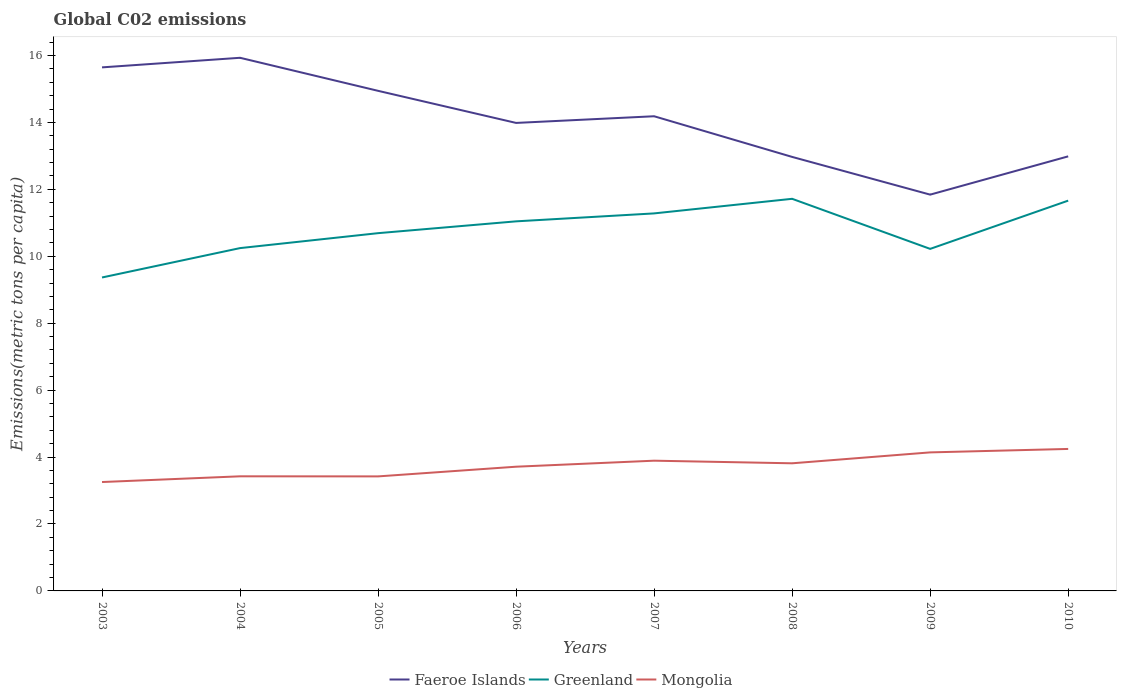Is the number of lines equal to the number of legend labels?
Keep it short and to the point. Yes. Across all years, what is the maximum amount of CO2 emitted in in Mongolia?
Provide a short and direct response. 3.25. What is the total amount of CO2 emitted in in Faeroe Islands in the graph?
Offer a terse response. 1.2. What is the difference between the highest and the second highest amount of CO2 emitted in in Faeroe Islands?
Provide a short and direct response. 4.09. What is the difference between the highest and the lowest amount of CO2 emitted in in Greenland?
Your answer should be compact. 4. How many lines are there?
Give a very brief answer. 3. Does the graph contain any zero values?
Keep it short and to the point. No. Does the graph contain grids?
Ensure brevity in your answer.  No. How are the legend labels stacked?
Offer a terse response. Horizontal. What is the title of the graph?
Your response must be concise. Global C02 emissions. What is the label or title of the Y-axis?
Provide a short and direct response. Emissions(metric tons per capita). What is the Emissions(metric tons per capita) in Faeroe Islands in 2003?
Offer a very short reply. 15.65. What is the Emissions(metric tons per capita) of Greenland in 2003?
Offer a very short reply. 9.37. What is the Emissions(metric tons per capita) in Mongolia in 2003?
Provide a short and direct response. 3.25. What is the Emissions(metric tons per capita) of Faeroe Islands in 2004?
Give a very brief answer. 15.93. What is the Emissions(metric tons per capita) of Greenland in 2004?
Give a very brief answer. 10.24. What is the Emissions(metric tons per capita) in Mongolia in 2004?
Ensure brevity in your answer.  3.43. What is the Emissions(metric tons per capita) in Faeroe Islands in 2005?
Your answer should be very brief. 14.95. What is the Emissions(metric tons per capita) of Greenland in 2005?
Make the answer very short. 10.69. What is the Emissions(metric tons per capita) in Mongolia in 2005?
Offer a very short reply. 3.42. What is the Emissions(metric tons per capita) in Faeroe Islands in 2006?
Keep it short and to the point. 13.99. What is the Emissions(metric tons per capita) in Greenland in 2006?
Offer a terse response. 11.04. What is the Emissions(metric tons per capita) of Mongolia in 2006?
Give a very brief answer. 3.71. What is the Emissions(metric tons per capita) in Faeroe Islands in 2007?
Ensure brevity in your answer.  14.19. What is the Emissions(metric tons per capita) in Greenland in 2007?
Provide a short and direct response. 11.28. What is the Emissions(metric tons per capita) in Mongolia in 2007?
Provide a short and direct response. 3.89. What is the Emissions(metric tons per capita) in Faeroe Islands in 2008?
Ensure brevity in your answer.  12.97. What is the Emissions(metric tons per capita) in Greenland in 2008?
Your answer should be very brief. 11.72. What is the Emissions(metric tons per capita) in Mongolia in 2008?
Provide a succinct answer. 3.81. What is the Emissions(metric tons per capita) in Faeroe Islands in 2009?
Ensure brevity in your answer.  11.84. What is the Emissions(metric tons per capita) of Greenland in 2009?
Provide a short and direct response. 10.22. What is the Emissions(metric tons per capita) of Mongolia in 2009?
Make the answer very short. 4.14. What is the Emissions(metric tons per capita) in Faeroe Islands in 2010?
Your answer should be compact. 12.99. What is the Emissions(metric tons per capita) of Greenland in 2010?
Your answer should be very brief. 11.66. What is the Emissions(metric tons per capita) in Mongolia in 2010?
Offer a terse response. 4.24. Across all years, what is the maximum Emissions(metric tons per capita) of Faeroe Islands?
Offer a very short reply. 15.93. Across all years, what is the maximum Emissions(metric tons per capita) in Greenland?
Ensure brevity in your answer.  11.72. Across all years, what is the maximum Emissions(metric tons per capita) in Mongolia?
Provide a short and direct response. 4.24. Across all years, what is the minimum Emissions(metric tons per capita) in Faeroe Islands?
Your answer should be very brief. 11.84. Across all years, what is the minimum Emissions(metric tons per capita) in Greenland?
Offer a very short reply. 9.37. Across all years, what is the minimum Emissions(metric tons per capita) in Mongolia?
Your answer should be compact. 3.25. What is the total Emissions(metric tons per capita) of Faeroe Islands in the graph?
Provide a succinct answer. 112.49. What is the total Emissions(metric tons per capita) of Greenland in the graph?
Offer a very short reply. 86.23. What is the total Emissions(metric tons per capita) of Mongolia in the graph?
Provide a succinct answer. 29.9. What is the difference between the Emissions(metric tons per capita) of Faeroe Islands in 2003 and that in 2004?
Offer a very short reply. -0.29. What is the difference between the Emissions(metric tons per capita) in Greenland in 2003 and that in 2004?
Provide a short and direct response. -0.88. What is the difference between the Emissions(metric tons per capita) of Mongolia in 2003 and that in 2004?
Your answer should be compact. -0.17. What is the difference between the Emissions(metric tons per capita) in Faeroe Islands in 2003 and that in 2005?
Offer a very short reply. 0.7. What is the difference between the Emissions(metric tons per capita) of Greenland in 2003 and that in 2005?
Make the answer very short. -1.32. What is the difference between the Emissions(metric tons per capita) in Mongolia in 2003 and that in 2005?
Your response must be concise. -0.17. What is the difference between the Emissions(metric tons per capita) in Faeroe Islands in 2003 and that in 2006?
Keep it short and to the point. 1.66. What is the difference between the Emissions(metric tons per capita) in Greenland in 2003 and that in 2006?
Your answer should be very brief. -1.68. What is the difference between the Emissions(metric tons per capita) of Mongolia in 2003 and that in 2006?
Your response must be concise. -0.46. What is the difference between the Emissions(metric tons per capita) of Faeroe Islands in 2003 and that in 2007?
Your response must be concise. 1.46. What is the difference between the Emissions(metric tons per capita) of Greenland in 2003 and that in 2007?
Your answer should be compact. -1.92. What is the difference between the Emissions(metric tons per capita) in Mongolia in 2003 and that in 2007?
Your response must be concise. -0.64. What is the difference between the Emissions(metric tons per capita) in Faeroe Islands in 2003 and that in 2008?
Provide a succinct answer. 2.68. What is the difference between the Emissions(metric tons per capita) in Greenland in 2003 and that in 2008?
Offer a very short reply. -2.35. What is the difference between the Emissions(metric tons per capita) of Mongolia in 2003 and that in 2008?
Your answer should be compact. -0.56. What is the difference between the Emissions(metric tons per capita) of Faeroe Islands in 2003 and that in 2009?
Make the answer very short. 3.8. What is the difference between the Emissions(metric tons per capita) of Greenland in 2003 and that in 2009?
Give a very brief answer. -0.85. What is the difference between the Emissions(metric tons per capita) of Mongolia in 2003 and that in 2009?
Ensure brevity in your answer.  -0.89. What is the difference between the Emissions(metric tons per capita) of Faeroe Islands in 2003 and that in 2010?
Offer a terse response. 2.66. What is the difference between the Emissions(metric tons per capita) in Greenland in 2003 and that in 2010?
Your response must be concise. -2.3. What is the difference between the Emissions(metric tons per capita) in Mongolia in 2003 and that in 2010?
Keep it short and to the point. -0.99. What is the difference between the Emissions(metric tons per capita) in Faeroe Islands in 2004 and that in 2005?
Keep it short and to the point. 0.99. What is the difference between the Emissions(metric tons per capita) of Greenland in 2004 and that in 2005?
Offer a terse response. -0.45. What is the difference between the Emissions(metric tons per capita) of Mongolia in 2004 and that in 2005?
Offer a very short reply. 0. What is the difference between the Emissions(metric tons per capita) in Faeroe Islands in 2004 and that in 2006?
Provide a succinct answer. 1.95. What is the difference between the Emissions(metric tons per capita) in Greenland in 2004 and that in 2006?
Ensure brevity in your answer.  -0.8. What is the difference between the Emissions(metric tons per capita) of Mongolia in 2004 and that in 2006?
Your answer should be very brief. -0.29. What is the difference between the Emissions(metric tons per capita) of Faeroe Islands in 2004 and that in 2007?
Your answer should be very brief. 1.75. What is the difference between the Emissions(metric tons per capita) in Greenland in 2004 and that in 2007?
Offer a very short reply. -1.04. What is the difference between the Emissions(metric tons per capita) of Mongolia in 2004 and that in 2007?
Ensure brevity in your answer.  -0.47. What is the difference between the Emissions(metric tons per capita) of Faeroe Islands in 2004 and that in 2008?
Offer a terse response. 2.96. What is the difference between the Emissions(metric tons per capita) of Greenland in 2004 and that in 2008?
Offer a very short reply. -1.47. What is the difference between the Emissions(metric tons per capita) of Mongolia in 2004 and that in 2008?
Ensure brevity in your answer.  -0.39. What is the difference between the Emissions(metric tons per capita) of Faeroe Islands in 2004 and that in 2009?
Give a very brief answer. 4.09. What is the difference between the Emissions(metric tons per capita) of Greenland in 2004 and that in 2009?
Offer a terse response. 0.02. What is the difference between the Emissions(metric tons per capita) in Mongolia in 2004 and that in 2009?
Make the answer very short. -0.71. What is the difference between the Emissions(metric tons per capita) of Faeroe Islands in 2004 and that in 2010?
Make the answer very short. 2.95. What is the difference between the Emissions(metric tons per capita) in Greenland in 2004 and that in 2010?
Ensure brevity in your answer.  -1.42. What is the difference between the Emissions(metric tons per capita) of Mongolia in 2004 and that in 2010?
Provide a short and direct response. -0.82. What is the difference between the Emissions(metric tons per capita) in Greenland in 2005 and that in 2006?
Your answer should be compact. -0.35. What is the difference between the Emissions(metric tons per capita) in Mongolia in 2005 and that in 2006?
Provide a succinct answer. -0.29. What is the difference between the Emissions(metric tons per capita) of Faeroe Islands in 2005 and that in 2007?
Your answer should be compact. 0.76. What is the difference between the Emissions(metric tons per capita) in Greenland in 2005 and that in 2007?
Keep it short and to the point. -0.59. What is the difference between the Emissions(metric tons per capita) in Mongolia in 2005 and that in 2007?
Your answer should be compact. -0.47. What is the difference between the Emissions(metric tons per capita) in Faeroe Islands in 2005 and that in 2008?
Provide a succinct answer. 1.97. What is the difference between the Emissions(metric tons per capita) of Greenland in 2005 and that in 2008?
Make the answer very short. -1.03. What is the difference between the Emissions(metric tons per capita) of Mongolia in 2005 and that in 2008?
Your answer should be very brief. -0.39. What is the difference between the Emissions(metric tons per capita) in Faeroe Islands in 2005 and that in 2009?
Ensure brevity in your answer.  3.1. What is the difference between the Emissions(metric tons per capita) in Greenland in 2005 and that in 2009?
Provide a short and direct response. 0.47. What is the difference between the Emissions(metric tons per capita) in Mongolia in 2005 and that in 2009?
Ensure brevity in your answer.  -0.72. What is the difference between the Emissions(metric tons per capita) of Faeroe Islands in 2005 and that in 2010?
Make the answer very short. 1.96. What is the difference between the Emissions(metric tons per capita) in Greenland in 2005 and that in 2010?
Ensure brevity in your answer.  -0.97. What is the difference between the Emissions(metric tons per capita) of Mongolia in 2005 and that in 2010?
Your response must be concise. -0.82. What is the difference between the Emissions(metric tons per capita) in Faeroe Islands in 2006 and that in 2007?
Provide a succinct answer. -0.2. What is the difference between the Emissions(metric tons per capita) in Greenland in 2006 and that in 2007?
Offer a terse response. -0.24. What is the difference between the Emissions(metric tons per capita) in Mongolia in 2006 and that in 2007?
Give a very brief answer. -0.18. What is the difference between the Emissions(metric tons per capita) in Greenland in 2006 and that in 2008?
Your response must be concise. -0.67. What is the difference between the Emissions(metric tons per capita) in Mongolia in 2006 and that in 2008?
Make the answer very short. -0.1. What is the difference between the Emissions(metric tons per capita) in Faeroe Islands in 2006 and that in 2009?
Offer a terse response. 2.14. What is the difference between the Emissions(metric tons per capita) in Greenland in 2006 and that in 2009?
Ensure brevity in your answer.  0.82. What is the difference between the Emissions(metric tons per capita) of Mongolia in 2006 and that in 2009?
Your answer should be very brief. -0.43. What is the difference between the Emissions(metric tons per capita) in Greenland in 2006 and that in 2010?
Keep it short and to the point. -0.62. What is the difference between the Emissions(metric tons per capita) of Mongolia in 2006 and that in 2010?
Ensure brevity in your answer.  -0.53. What is the difference between the Emissions(metric tons per capita) of Faeroe Islands in 2007 and that in 2008?
Give a very brief answer. 1.22. What is the difference between the Emissions(metric tons per capita) of Greenland in 2007 and that in 2008?
Your response must be concise. -0.44. What is the difference between the Emissions(metric tons per capita) of Mongolia in 2007 and that in 2008?
Give a very brief answer. 0.08. What is the difference between the Emissions(metric tons per capita) of Faeroe Islands in 2007 and that in 2009?
Make the answer very short. 2.34. What is the difference between the Emissions(metric tons per capita) of Greenland in 2007 and that in 2009?
Your answer should be compact. 1.06. What is the difference between the Emissions(metric tons per capita) in Mongolia in 2007 and that in 2009?
Provide a succinct answer. -0.25. What is the difference between the Emissions(metric tons per capita) of Faeroe Islands in 2007 and that in 2010?
Your answer should be very brief. 1.2. What is the difference between the Emissions(metric tons per capita) of Greenland in 2007 and that in 2010?
Offer a terse response. -0.38. What is the difference between the Emissions(metric tons per capita) in Mongolia in 2007 and that in 2010?
Your answer should be very brief. -0.35. What is the difference between the Emissions(metric tons per capita) of Faeroe Islands in 2008 and that in 2009?
Make the answer very short. 1.13. What is the difference between the Emissions(metric tons per capita) of Greenland in 2008 and that in 2009?
Give a very brief answer. 1.5. What is the difference between the Emissions(metric tons per capita) of Mongolia in 2008 and that in 2009?
Give a very brief answer. -0.33. What is the difference between the Emissions(metric tons per capita) in Faeroe Islands in 2008 and that in 2010?
Give a very brief answer. -0.02. What is the difference between the Emissions(metric tons per capita) of Greenland in 2008 and that in 2010?
Provide a succinct answer. 0.05. What is the difference between the Emissions(metric tons per capita) of Mongolia in 2008 and that in 2010?
Your answer should be compact. -0.43. What is the difference between the Emissions(metric tons per capita) in Faeroe Islands in 2009 and that in 2010?
Your answer should be very brief. -1.14. What is the difference between the Emissions(metric tons per capita) of Greenland in 2009 and that in 2010?
Provide a succinct answer. -1.44. What is the difference between the Emissions(metric tons per capita) of Mongolia in 2009 and that in 2010?
Provide a succinct answer. -0.1. What is the difference between the Emissions(metric tons per capita) of Faeroe Islands in 2003 and the Emissions(metric tons per capita) of Greenland in 2004?
Provide a short and direct response. 5.4. What is the difference between the Emissions(metric tons per capita) in Faeroe Islands in 2003 and the Emissions(metric tons per capita) in Mongolia in 2004?
Your answer should be compact. 12.22. What is the difference between the Emissions(metric tons per capita) of Greenland in 2003 and the Emissions(metric tons per capita) of Mongolia in 2004?
Offer a terse response. 5.94. What is the difference between the Emissions(metric tons per capita) in Faeroe Islands in 2003 and the Emissions(metric tons per capita) in Greenland in 2005?
Your answer should be very brief. 4.95. What is the difference between the Emissions(metric tons per capita) in Faeroe Islands in 2003 and the Emissions(metric tons per capita) in Mongolia in 2005?
Your response must be concise. 12.22. What is the difference between the Emissions(metric tons per capita) of Greenland in 2003 and the Emissions(metric tons per capita) of Mongolia in 2005?
Offer a terse response. 5.94. What is the difference between the Emissions(metric tons per capita) in Faeroe Islands in 2003 and the Emissions(metric tons per capita) in Greenland in 2006?
Keep it short and to the point. 4.6. What is the difference between the Emissions(metric tons per capita) in Faeroe Islands in 2003 and the Emissions(metric tons per capita) in Mongolia in 2006?
Give a very brief answer. 11.93. What is the difference between the Emissions(metric tons per capita) of Greenland in 2003 and the Emissions(metric tons per capita) of Mongolia in 2006?
Give a very brief answer. 5.65. What is the difference between the Emissions(metric tons per capita) of Faeroe Islands in 2003 and the Emissions(metric tons per capita) of Greenland in 2007?
Provide a short and direct response. 4.36. What is the difference between the Emissions(metric tons per capita) in Faeroe Islands in 2003 and the Emissions(metric tons per capita) in Mongolia in 2007?
Provide a succinct answer. 11.75. What is the difference between the Emissions(metric tons per capita) in Greenland in 2003 and the Emissions(metric tons per capita) in Mongolia in 2007?
Offer a terse response. 5.47. What is the difference between the Emissions(metric tons per capita) in Faeroe Islands in 2003 and the Emissions(metric tons per capita) in Greenland in 2008?
Provide a succinct answer. 3.93. What is the difference between the Emissions(metric tons per capita) in Faeroe Islands in 2003 and the Emissions(metric tons per capita) in Mongolia in 2008?
Ensure brevity in your answer.  11.83. What is the difference between the Emissions(metric tons per capita) of Greenland in 2003 and the Emissions(metric tons per capita) of Mongolia in 2008?
Your response must be concise. 5.55. What is the difference between the Emissions(metric tons per capita) of Faeroe Islands in 2003 and the Emissions(metric tons per capita) of Greenland in 2009?
Provide a succinct answer. 5.42. What is the difference between the Emissions(metric tons per capita) in Faeroe Islands in 2003 and the Emissions(metric tons per capita) in Mongolia in 2009?
Give a very brief answer. 11.51. What is the difference between the Emissions(metric tons per capita) of Greenland in 2003 and the Emissions(metric tons per capita) of Mongolia in 2009?
Your answer should be very brief. 5.23. What is the difference between the Emissions(metric tons per capita) in Faeroe Islands in 2003 and the Emissions(metric tons per capita) in Greenland in 2010?
Give a very brief answer. 3.98. What is the difference between the Emissions(metric tons per capita) of Faeroe Islands in 2003 and the Emissions(metric tons per capita) of Mongolia in 2010?
Your response must be concise. 11.4. What is the difference between the Emissions(metric tons per capita) in Greenland in 2003 and the Emissions(metric tons per capita) in Mongolia in 2010?
Ensure brevity in your answer.  5.12. What is the difference between the Emissions(metric tons per capita) in Faeroe Islands in 2004 and the Emissions(metric tons per capita) in Greenland in 2005?
Your answer should be compact. 5.24. What is the difference between the Emissions(metric tons per capita) of Faeroe Islands in 2004 and the Emissions(metric tons per capita) of Mongolia in 2005?
Make the answer very short. 12.51. What is the difference between the Emissions(metric tons per capita) in Greenland in 2004 and the Emissions(metric tons per capita) in Mongolia in 2005?
Provide a short and direct response. 6.82. What is the difference between the Emissions(metric tons per capita) of Faeroe Islands in 2004 and the Emissions(metric tons per capita) of Greenland in 2006?
Give a very brief answer. 4.89. What is the difference between the Emissions(metric tons per capita) of Faeroe Islands in 2004 and the Emissions(metric tons per capita) of Mongolia in 2006?
Your answer should be very brief. 12.22. What is the difference between the Emissions(metric tons per capita) in Greenland in 2004 and the Emissions(metric tons per capita) in Mongolia in 2006?
Provide a succinct answer. 6.53. What is the difference between the Emissions(metric tons per capita) in Faeroe Islands in 2004 and the Emissions(metric tons per capita) in Greenland in 2007?
Your answer should be compact. 4.65. What is the difference between the Emissions(metric tons per capita) of Faeroe Islands in 2004 and the Emissions(metric tons per capita) of Mongolia in 2007?
Your answer should be compact. 12.04. What is the difference between the Emissions(metric tons per capita) in Greenland in 2004 and the Emissions(metric tons per capita) in Mongolia in 2007?
Your answer should be compact. 6.35. What is the difference between the Emissions(metric tons per capita) in Faeroe Islands in 2004 and the Emissions(metric tons per capita) in Greenland in 2008?
Provide a short and direct response. 4.21. What is the difference between the Emissions(metric tons per capita) of Faeroe Islands in 2004 and the Emissions(metric tons per capita) of Mongolia in 2008?
Ensure brevity in your answer.  12.12. What is the difference between the Emissions(metric tons per capita) in Greenland in 2004 and the Emissions(metric tons per capita) in Mongolia in 2008?
Ensure brevity in your answer.  6.43. What is the difference between the Emissions(metric tons per capita) of Faeroe Islands in 2004 and the Emissions(metric tons per capita) of Greenland in 2009?
Offer a very short reply. 5.71. What is the difference between the Emissions(metric tons per capita) in Faeroe Islands in 2004 and the Emissions(metric tons per capita) in Mongolia in 2009?
Keep it short and to the point. 11.79. What is the difference between the Emissions(metric tons per capita) of Greenland in 2004 and the Emissions(metric tons per capita) of Mongolia in 2009?
Ensure brevity in your answer.  6.1. What is the difference between the Emissions(metric tons per capita) of Faeroe Islands in 2004 and the Emissions(metric tons per capita) of Greenland in 2010?
Provide a succinct answer. 4.27. What is the difference between the Emissions(metric tons per capita) of Faeroe Islands in 2004 and the Emissions(metric tons per capita) of Mongolia in 2010?
Provide a succinct answer. 11.69. What is the difference between the Emissions(metric tons per capita) of Greenland in 2004 and the Emissions(metric tons per capita) of Mongolia in 2010?
Offer a terse response. 6. What is the difference between the Emissions(metric tons per capita) of Faeroe Islands in 2005 and the Emissions(metric tons per capita) of Greenland in 2006?
Offer a very short reply. 3.9. What is the difference between the Emissions(metric tons per capita) in Faeroe Islands in 2005 and the Emissions(metric tons per capita) in Mongolia in 2006?
Give a very brief answer. 11.23. What is the difference between the Emissions(metric tons per capita) in Greenland in 2005 and the Emissions(metric tons per capita) in Mongolia in 2006?
Ensure brevity in your answer.  6.98. What is the difference between the Emissions(metric tons per capita) in Faeroe Islands in 2005 and the Emissions(metric tons per capita) in Greenland in 2007?
Make the answer very short. 3.66. What is the difference between the Emissions(metric tons per capita) of Faeroe Islands in 2005 and the Emissions(metric tons per capita) of Mongolia in 2007?
Make the answer very short. 11.05. What is the difference between the Emissions(metric tons per capita) of Greenland in 2005 and the Emissions(metric tons per capita) of Mongolia in 2007?
Ensure brevity in your answer.  6.8. What is the difference between the Emissions(metric tons per capita) in Faeroe Islands in 2005 and the Emissions(metric tons per capita) in Greenland in 2008?
Offer a terse response. 3.23. What is the difference between the Emissions(metric tons per capita) in Faeroe Islands in 2005 and the Emissions(metric tons per capita) in Mongolia in 2008?
Your answer should be very brief. 11.13. What is the difference between the Emissions(metric tons per capita) of Greenland in 2005 and the Emissions(metric tons per capita) of Mongolia in 2008?
Provide a succinct answer. 6.88. What is the difference between the Emissions(metric tons per capita) in Faeroe Islands in 2005 and the Emissions(metric tons per capita) in Greenland in 2009?
Your answer should be very brief. 4.72. What is the difference between the Emissions(metric tons per capita) in Faeroe Islands in 2005 and the Emissions(metric tons per capita) in Mongolia in 2009?
Your answer should be compact. 10.8. What is the difference between the Emissions(metric tons per capita) in Greenland in 2005 and the Emissions(metric tons per capita) in Mongolia in 2009?
Keep it short and to the point. 6.55. What is the difference between the Emissions(metric tons per capita) in Faeroe Islands in 2005 and the Emissions(metric tons per capita) in Greenland in 2010?
Make the answer very short. 3.28. What is the difference between the Emissions(metric tons per capita) in Faeroe Islands in 2005 and the Emissions(metric tons per capita) in Mongolia in 2010?
Make the answer very short. 10.7. What is the difference between the Emissions(metric tons per capita) in Greenland in 2005 and the Emissions(metric tons per capita) in Mongolia in 2010?
Provide a short and direct response. 6.45. What is the difference between the Emissions(metric tons per capita) of Faeroe Islands in 2006 and the Emissions(metric tons per capita) of Greenland in 2007?
Provide a short and direct response. 2.7. What is the difference between the Emissions(metric tons per capita) of Faeroe Islands in 2006 and the Emissions(metric tons per capita) of Mongolia in 2007?
Offer a terse response. 10.09. What is the difference between the Emissions(metric tons per capita) of Greenland in 2006 and the Emissions(metric tons per capita) of Mongolia in 2007?
Your answer should be compact. 7.15. What is the difference between the Emissions(metric tons per capita) in Faeroe Islands in 2006 and the Emissions(metric tons per capita) in Greenland in 2008?
Ensure brevity in your answer.  2.27. What is the difference between the Emissions(metric tons per capita) in Faeroe Islands in 2006 and the Emissions(metric tons per capita) in Mongolia in 2008?
Your response must be concise. 10.17. What is the difference between the Emissions(metric tons per capita) of Greenland in 2006 and the Emissions(metric tons per capita) of Mongolia in 2008?
Your answer should be compact. 7.23. What is the difference between the Emissions(metric tons per capita) of Faeroe Islands in 2006 and the Emissions(metric tons per capita) of Greenland in 2009?
Make the answer very short. 3.76. What is the difference between the Emissions(metric tons per capita) in Faeroe Islands in 2006 and the Emissions(metric tons per capita) in Mongolia in 2009?
Offer a very short reply. 9.85. What is the difference between the Emissions(metric tons per capita) of Greenland in 2006 and the Emissions(metric tons per capita) of Mongolia in 2009?
Provide a succinct answer. 6.9. What is the difference between the Emissions(metric tons per capita) in Faeroe Islands in 2006 and the Emissions(metric tons per capita) in Greenland in 2010?
Provide a short and direct response. 2.32. What is the difference between the Emissions(metric tons per capita) in Faeroe Islands in 2006 and the Emissions(metric tons per capita) in Mongolia in 2010?
Your answer should be compact. 9.74. What is the difference between the Emissions(metric tons per capita) of Greenland in 2006 and the Emissions(metric tons per capita) of Mongolia in 2010?
Offer a terse response. 6.8. What is the difference between the Emissions(metric tons per capita) in Faeroe Islands in 2007 and the Emissions(metric tons per capita) in Greenland in 2008?
Offer a very short reply. 2.47. What is the difference between the Emissions(metric tons per capita) in Faeroe Islands in 2007 and the Emissions(metric tons per capita) in Mongolia in 2008?
Your answer should be compact. 10.37. What is the difference between the Emissions(metric tons per capita) in Greenland in 2007 and the Emissions(metric tons per capita) in Mongolia in 2008?
Your answer should be very brief. 7.47. What is the difference between the Emissions(metric tons per capita) in Faeroe Islands in 2007 and the Emissions(metric tons per capita) in Greenland in 2009?
Make the answer very short. 3.96. What is the difference between the Emissions(metric tons per capita) in Faeroe Islands in 2007 and the Emissions(metric tons per capita) in Mongolia in 2009?
Offer a terse response. 10.05. What is the difference between the Emissions(metric tons per capita) of Greenland in 2007 and the Emissions(metric tons per capita) of Mongolia in 2009?
Offer a terse response. 7.14. What is the difference between the Emissions(metric tons per capita) of Faeroe Islands in 2007 and the Emissions(metric tons per capita) of Greenland in 2010?
Your response must be concise. 2.52. What is the difference between the Emissions(metric tons per capita) of Faeroe Islands in 2007 and the Emissions(metric tons per capita) of Mongolia in 2010?
Provide a short and direct response. 9.94. What is the difference between the Emissions(metric tons per capita) in Greenland in 2007 and the Emissions(metric tons per capita) in Mongolia in 2010?
Provide a short and direct response. 7.04. What is the difference between the Emissions(metric tons per capita) in Faeroe Islands in 2008 and the Emissions(metric tons per capita) in Greenland in 2009?
Ensure brevity in your answer.  2.75. What is the difference between the Emissions(metric tons per capita) of Faeroe Islands in 2008 and the Emissions(metric tons per capita) of Mongolia in 2009?
Your response must be concise. 8.83. What is the difference between the Emissions(metric tons per capita) of Greenland in 2008 and the Emissions(metric tons per capita) of Mongolia in 2009?
Your answer should be very brief. 7.58. What is the difference between the Emissions(metric tons per capita) of Faeroe Islands in 2008 and the Emissions(metric tons per capita) of Greenland in 2010?
Offer a very short reply. 1.31. What is the difference between the Emissions(metric tons per capita) in Faeroe Islands in 2008 and the Emissions(metric tons per capita) in Mongolia in 2010?
Your response must be concise. 8.73. What is the difference between the Emissions(metric tons per capita) in Greenland in 2008 and the Emissions(metric tons per capita) in Mongolia in 2010?
Your answer should be very brief. 7.47. What is the difference between the Emissions(metric tons per capita) in Faeroe Islands in 2009 and the Emissions(metric tons per capita) in Greenland in 2010?
Offer a terse response. 0.18. What is the difference between the Emissions(metric tons per capita) of Faeroe Islands in 2009 and the Emissions(metric tons per capita) of Mongolia in 2010?
Offer a terse response. 7.6. What is the difference between the Emissions(metric tons per capita) of Greenland in 2009 and the Emissions(metric tons per capita) of Mongolia in 2010?
Make the answer very short. 5.98. What is the average Emissions(metric tons per capita) of Faeroe Islands per year?
Your answer should be compact. 14.06. What is the average Emissions(metric tons per capita) in Greenland per year?
Offer a very short reply. 10.78. What is the average Emissions(metric tons per capita) in Mongolia per year?
Your answer should be compact. 3.74. In the year 2003, what is the difference between the Emissions(metric tons per capita) of Faeroe Islands and Emissions(metric tons per capita) of Greenland?
Offer a very short reply. 6.28. In the year 2003, what is the difference between the Emissions(metric tons per capita) of Faeroe Islands and Emissions(metric tons per capita) of Mongolia?
Ensure brevity in your answer.  12.39. In the year 2003, what is the difference between the Emissions(metric tons per capita) of Greenland and Emissions(metric tons per capita) of Mongolia?
Provide a short and direct response. 6.11. In the year 2004, what is the difference between the Emissions(metric tons per capita) in Faeroe Islands and Emissions(metric tons per capita) in Greenland?
Your answer should be very brief. 5.69. In the year 2004, what is the difference between the Emissions(metric tons per capita) in Faeroe Islands and Emissions(metric tons per capita) in Mongolia?
Keep it short and to the point. 12.51. In the year 2004, what is the difference between the Emissions(metric tons per capita) in Greenland and Emissions(metric tons per capita) in Mongolia?
Your answer should be compact. 6.82. In the year 2005, what is the difference between the Emissions(metric tons per capita) in Faeroe Islands and Emissions(metric tons per capita) in Greenland?
Offer a very short reply. 4.25. In the year 2005, what is the difference between the Emissions(metric tons per capita) of Faeroe Islands and Emissions(metric tons per capita) of Mongolia?
Ensure brevity in your answer.  11.52. In the year 2005, what is the difference between the Emissions(metric tons per capita) in Greenland and Emissions(metric tons per capita) in Mongolia?
Keep it short and to the point. 7.27. In the year 2006, what is the difference between the Emissions(metric tons per capita) of Faeroe Islands and Emissions(metric tons per capita) of Greenland?
Your answer should be very brief. 2.94. In the year 2006, what is the difference between the Emissions(metric tons per capita) in Faeroe Islands and Emissions(metric tons per capita) in Mongolia?
Give a very brief answer. 10.27. In the year 2006, what is the difference between the Emissions(metric tons per capita) of Greenland and Emissions(metric tons per capita) of Mongolia?
Ensure brevity in your answer.  7.33. In the year 2007, what is the difference between the Emissions(metric tons per capita) in Faeroe Islands and Emissions(metric tons per capita) in Greenland?
Your response must be concise. 2.9. In the year 2007, what is the difference between the Emissions(metric tons per capita) of Faeroe Islands and Emissions(metric tons per capita) of Mongolia?
Your response must be concise. 10.29. In the year 2007, what is the difference between the Emissions(metric tons per capita) of Greenland and Emissions(metric tons per capita) of Mongolia?
Give a very brief answer. 7.39. In the year 2008, what is the difference between the Emissions(metric tons per capita) in Faeroe Islands and Emissions(metric tons per capita) in Greenland?
Ensure brevity in your answer.  1.25. In the year 2008, what is the difference between the Emissions(metric tons per capita) in Faeroe Islands and Emissions(metric tons per capita) in Mongolia?
Your answer should be compact. 9.16. In the year 2008, what is the difference between the Emissions(metric tons per capita) in Greenland and Emissions(metric tons per capita) in Mongolia?
Make the answer very short. 7.9. In the year 2009, what is the difference between the Emissions(metric tons per capita) in Faeroe Islands and Emissions(metric tons per capita) in Greenland?
Provide a succinct answer. 1.62. In the year 2009, what is the difference between the Emissions(metric tons per capita) of Faeroe Islands and Emissions(metric tons per capita) of Mongolia?
Your answer should be compact. 7.7. In the year 2009, what is the difference between the Emissions(metric tons per capita) of Greenland and Emissions(metric tons per capita) of Mongolia?
Offer a very short reply. 6.08. In the year 2010, what is the difference between the Emissions(metric tons per capita) in Faeroe Islands and Emissions(metric tons per capita) in Greenland?
Your response must be concise. 1.32. In the year 2010, what is the difference between the Emissions(metric tons per capita) in Faeroe Islands and Emissions(metric tons per capita) in Mongolia?
Ensure brevity in your answer.  8.74. In the year 2010, what is the difference between the Emissions(metric tons per capita) of Greenland and Emissions(metric tons per capita) of Mongolia?
Your answer should be compact. 7.42. What is the ratio of the Emissions(metric tons per capita) of Faeroe Islands in 2003 to that in 2004?
Your response must be concise. 0.98. What is the ratio of the Emissions(metric tons per capita) of Greenland in 2003 to that in 2004?
Offer a very short reply. 0.91. What is the ratio of the Emissions(metric tons per capita) of Mongolia in 2003 to that in 2004?
Provide a short and direct response. 0.95. What is the ratio of the Emissions(metric tons per capita) in Faeroe Islands in 2003 to that in 2005?
Your response must be concise. 1.05. What is the ratio of the Emissions(metric tons per capita) of Greenland in 2003 to that in 2005?
Offer a very short reply. 0.88. What is the ratio of the Emissions(metric tons per capita) of Mongolia in 2003 to that in 2005?
Keep it short and to the point. 0.95. What is the ratio of the Emissions(metric tons per capita) of Faeroe Islands in 2003 to that in 2006?
Give a very brief answer. 1.12. What is the ratio of the Emissions(metric tons per capita) of Greenland in 2003 to that in 2006?
Your response must be concise. 0.85. What is the ratio of the Emissions(metric tons per capita) of Mongolia in 2003 to that in 2006?
Provide a short and direct response. 0.88. What is the ratio of the Emissions(metric tons per capita) of Faeroe Islands in 2003 to that in 2007?
Offer a terse response. 1.1. What is the ratio of the Emissions(metric tons per capita) of Greenland in 2003 to that in 2007?
Your answer should be compact. 0.83. What is the ratio of the Emissions(metric tons per capita) in Mongolia in 2003 to that in 2007?
Offer a terse response. 0.84. What is the ratio of the Emissions(metric tons per capita) of Faeroe Islands in 2003 to that in 2008?
Offer a very short reply. 1.21. What is the ratio of the Emissions(metric tons per capita) of Greenland in 2003 to that in 2008?
Offer a terse response. 0.8. What is the ratio of the Emissions(metric tons per capita) in Mongolia in 2003 to that in 2008?
Give a very brief answer. 0.85. What is the ratio of the Emissions(metric tons per capita) in Faeroe Islands in 2003 to that in 2009?
Your answer should be very brief. 1.32. What is the ratio of the Emissions(metric tons per capita) in Greenland in 2003 to that in 2009?
Give a very brief answer. 0.92. What is the ratio of the Emissions(metric tons per capita) in Mongolia in 2003 to that in 2009?
Provide a succinct answer. 0.79. What is the ratio of the Emissions(metric tons per capita) of Faeroe Islands in 2003 to that in 2010?
Offer a terse response. 1.2. What is the ratio of the Emissions(metric tons per capita) in Greenland in 2003 to that in 2010?
Your response must be concise. 0.8. What is the ratio of the Emissions(metric tons per capita) of Mongolia in 2003 to that in 2010?
Ensure brevity in your answer.  0.77. What is the ratio of the Emissions(metric tons per capita) of Faeroe Islands in 2004 to that in 2005?
Keep it short and to the point. 1.07. What is the ratio of the Emissions(metric tons per capita) of Greenland in 2004 to that in 2005?
Ensure brevity in your answer.  0.96. What is the ratio of the Emissions(metric tons per capita) of Mongolia in 2004 to that in 2005?
Ensure brevity in your answer.  1. What is the ratio of the Emissions(metric tons per capita) of Faeroe Islands in 2004 to that in 2006?
Provide a succinct answer. 1.14. What is the ratio of the Emissions(metric tons per capita) in Greenland in 2004 to that in 2006?
Keep it short and to the point. 0.93. What is the ratio of the Emissions(metric tons per capita) in Mongolia in 2004 to that in 2006?
Your answer should be compact. 0.92. What is the ratio of the Emissions(metric tons per capita) in Faeroe Islands in 2004 to that in 2007?
Your answer should be very brief. 1.12. What is the ratio of the Emissions(metric tons per capita) of Greenland in 2004 to that in 2007?
Your answer should be very brief. 0.91. What is the ratio of the Emissions(metric tons per capita) of Mongolia in 2004 to that in 2007?
Keep it short and to the point. 0.88. What is the ratio of the Emissions(metric tons per capita) in Faeroe Islands in 2004 to that in 2008?
Give a very brief answer. 1.23. What is the ratio of the Emissions(metric tons per capita) in Greenland in 2004 to that in 2008?
Ensure brevity in your answer.  0.87. What is the ratio of the Emissions(metric tons per capita) of Mongolia in 2004 to that in 2008?
Keep it short and to the point. 0.9. What is the ratio of the Emissions(metric tons per capita) in Faeroe Islands in 2004 to that in 2009?
Keep it short and to the point. 1.35. What is the ratio of the Emissions(metric tons per capita) of Greenland in 2004 to that in 2009?
Keep it short and to the point. 1. What is the ratio of the Emissions(metric tons per capita) in Mongolia in 2004 to that in 2009?
Offer a very short reply. 0.83. What is the ratio of the Emissions(metric tons per capita) in Faeroe Islands in 2004 to that in 2010?
Offer a terse response. 1.23. What is the ratio of the Emissions(metric tons per capita) in Greenland in 2004 to that in 2010?
Give a very brief answer. 0.88. What is the ratio of the Emissions(metric tons per capita) in Mongolia in 2004 to that in 2010?
Your response must be concise. 0.81. What is the ratio of the Emissions(metric tons per capita) in Faeroe Islands in 2005 to that in 2006?
Ensure brevity in your answer.  1.07. What is the ratio of the Emissions(metric tons per capita) in Mongolia in 2005 to that in 2006?
Make the answer very short. 0.92. What is the ratio of the Emissions(metric tons per capita) in Faeroe Islands in 2005 to that in 2007?
Keep it short and to the point. 1.05. What is the ratio of the Emissions(metric tons per capita) of Greenland in 2005 to that in 2007?
Offer a terse response. 0.95. What is the ratio of the Emissions(metric tons per capita) in Mongolia in 2005 to that in 2007?
Provide a succinct answer. 0.88. What is the ratio of the Emissions(metric tons per capita) in Faeroe Islands in 2005 to that in 2008?
Your answer should be compact. 1.15. What is the ratio of the Emissions(metric tons per capita) in Greenland in 2005 to that in 2008?
Keep it short and to the point. 0.91. What is the ratio of the Emissions(metric tons per capita) in Mongolia in 2005 to that in 2008?
Ensure brevity in your answer.  0.9. What is the ratio of the Emissions(metric tons per capita) of Faeroe Islands in 2005 to that in 2009?
Provide a short and direct response. 1.26. What is the ratio of the Emissions(metric tons per capita) of Greenland in 2005 to that in 2009?
Give a very brief answer. 1.05. What is the ratio of the Emissions(metric tons per capita) in Mongolia in 2005 to that in 2009?
Make the answer very short. 0.83. What is the ratio of the Emissions(metric tons per capita) in Faeroe Islands in 2005 to that in 2010?
Your answer should be compact. 1.15. What is the ratio of the Emissions(metric tons per capita) of Greenland in 2005 to that in 2010?
Provide a succinct answer. 0.92. What is the ratio of the Emissions(metric tons per capita) of Mongolia in 2005 to that in 2010?
Your response must be concise. 0.81. What is the ratio of the Emissions(metric tons per capita) in Faeroe Islands in 2006 to that in 2007?
Make the answer very short. 0.99. What is the ratio of the Emissions(metric tons per capita) of Mongolia in 2006 to that in 2007?
Provide a short and direct response. 0.95. What is the ratio of the Emissions(metric tons per capita) in Faeroe Islands in 2006 to that in 2008?
Offer a terse response. 1.08. What is the ratio of the Emissions(metric tons per capita) in Greenland in 2006 to that in 2008?
Give a very brief answer. 0.94. What is the ratio of the Emissions(metric tons per capita) in Mongolia in 2006 to that in 2008?
Offer a terse response. 0.97. What is the ratio of the Emissions(metric tons per capita) of Faeroe Islands in 2006 to that in 2009?
Make the answer very short. 1.18. What is the ratio of the Emissions(metric tons per capita) in Greenland in 2006 to that in 2009?
Keep it short and to the point. 1.08. What is the ratio of the Emissions(metric tons per capita) in Mongolia in 2006 to that in 2009?
Provide a succinct answer. 0.9. What is the ratio of the Emissions(metric tons per capita) in Faeroe Islands in 2006 to that in 2010?
Offer a very short reply. 1.08. What is the ratio of the Emissions(metric tons per capita) in Greenland in 2006 to that in 2010?
Your answer should be compact. 0.95. What is the ratio of the Emissions(metric tons per capita) in Mongolia in 2006 to that in 2010?
Your answer should be very brief. 0.87. What is the ratio of the Emissions(metric tons per capita) of Faeroe Islands in 2007 to that in 2008?
Provide a short and direct response. 1.09. What is the ratio of the Emissions(metric tons per capita) in Greenland in 2007 to that in 2008?
Keep it short and to the point. 0.96. What is the ratio of the Emissions(metric tons per capita) of Mongolia in 2007 to that in 2008?
Your answer should be compact. 1.02. What is the ratio of the Emissions(metric tons per capita) of Faeroe Islands in 2007 to that in 2009?
Your answer should be very brief. 1.2. What is the ratio of the Emissions(metric tons per capita) in Greenland in 2007 to that in 2009?
Make the answer very short. 1.1. What is the ratio of the Emissions(metric tons per capita) of Mongolia in 2007 to that in 2009?
Give a very brief answer. 0.94. What is the ratio of the Emissions(metric tons per capita) of Faeroe Islands in 2007 to that in 2010?
Provide a short and direct response. 1.09. What is the ratio of the Emissions(metric tons per capita) of Greenland in 2007 to that in 2010?
Provide a short and direct response. 0.97. What is the ratio of the Emissions(metric tons per capita) of Mongolia in 2007 to that in 2010?
Ensure brevity in your answer.  0.92. What is the ratio of the Emissions(metric tons per capita) of Faeroe Islands in 2008 to that in 2009?
Provide a short and direct response. 1.1. What is the ratio of the Emissions(metric tons per capita) of Greenland in 2008 to that in 2009?
Give a very brief answer. 1.15. What is the ratio of the Emissions(metric tons per capita) in Mongolia in 2008 to that in 2009?
Your answer should be very brief. 0.92. What is the ratio of the Emissions(metric tons per capita) in Faeroe Islands in 2008 to that in 2010?
Your answer should be compact. 1. What is the ratio of the Emissions(metric tons per capita) in Mongolia in 2008 to that in 2010?
Provide a short and direct response. 0.9. What is the ratio of the Emissions(metric tons per capita) of Faeroe Islands in 2009 to that in 2010?
Your response must be concise. 0.91. What is the ratio of the Emissions(metric tons per capita) in Greenland in 2009 to that in 2010?
Ensure brevity in your answer.  0.88. What is the ratio of the Emissions(metric tons per capita) in Mongolia in 2009 to that in 2010?
Offer a terse response. 0.98. What is the difference between the highest and the second highest Emissions(metric tons per capita) in Faeroe Islands?
Ensure brevity in your answer.  0.29. What is the difference between the highest and the second highest Emissions(metric tons per capita) in Greenland?
Ensure brevity in your answer.  0.05. What is the difference between the highest and the second highest Emissions(metric tons per capita) of Mongolia?
Provide a short and direct response. 0.1. What is the difference between the highest and the lowest Emissions(metric tons per capita) of Faeroe Islands?
Give a very brief answer. 4.09. What is the difference between the highest and the lowest Emissions(metric tons per capita) in Greenland?
Offer a very short reply. 2.35. What is the difference between the highest and the lowest Emissions(metric tons per capita) in Mongolia?
Make the answer very short. 0.99. 